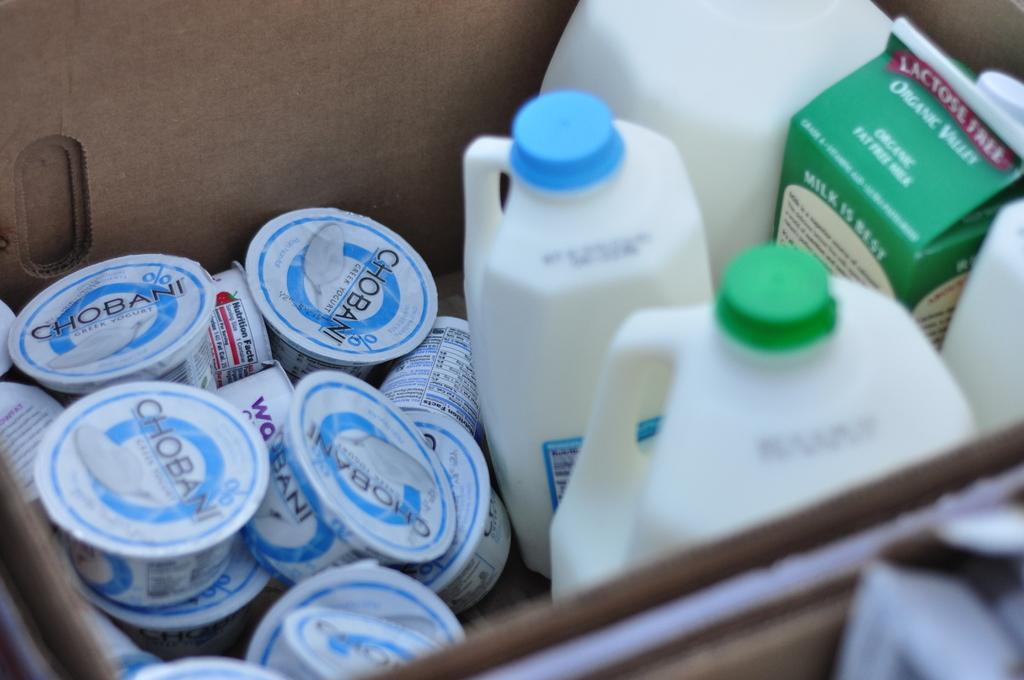Describe this image in one or two sentences. The picture consists of some small boxes and some cans and tetra pack are present in the box. 